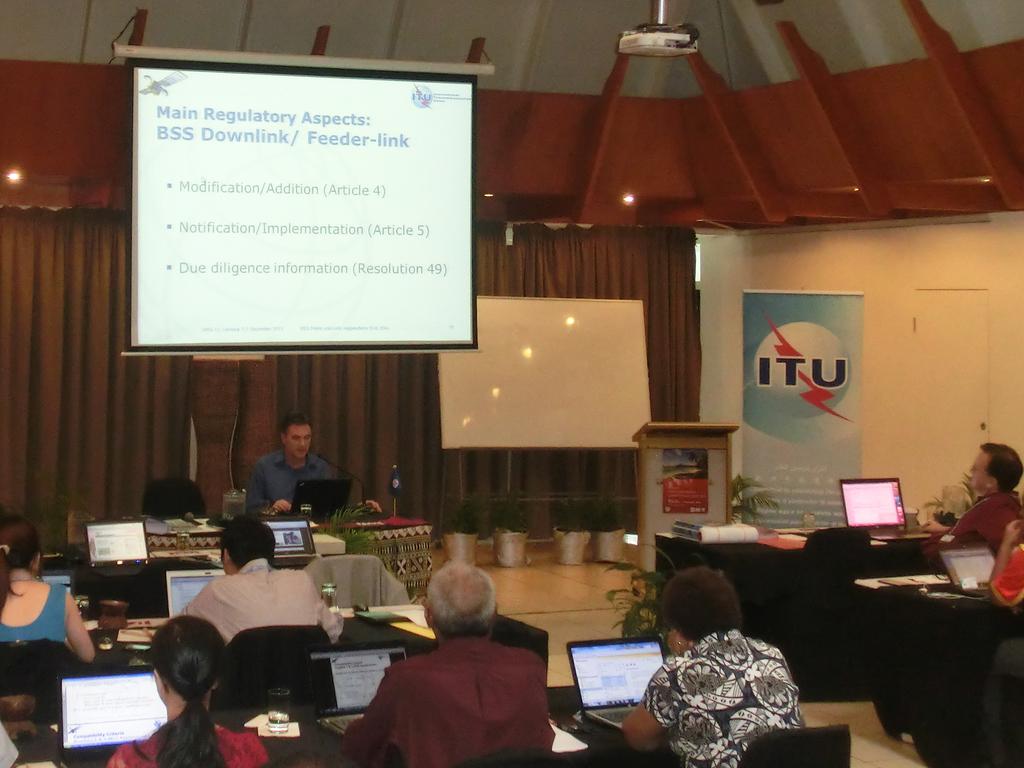What is on the right ad?
Keep it short and to the point. Itu. 